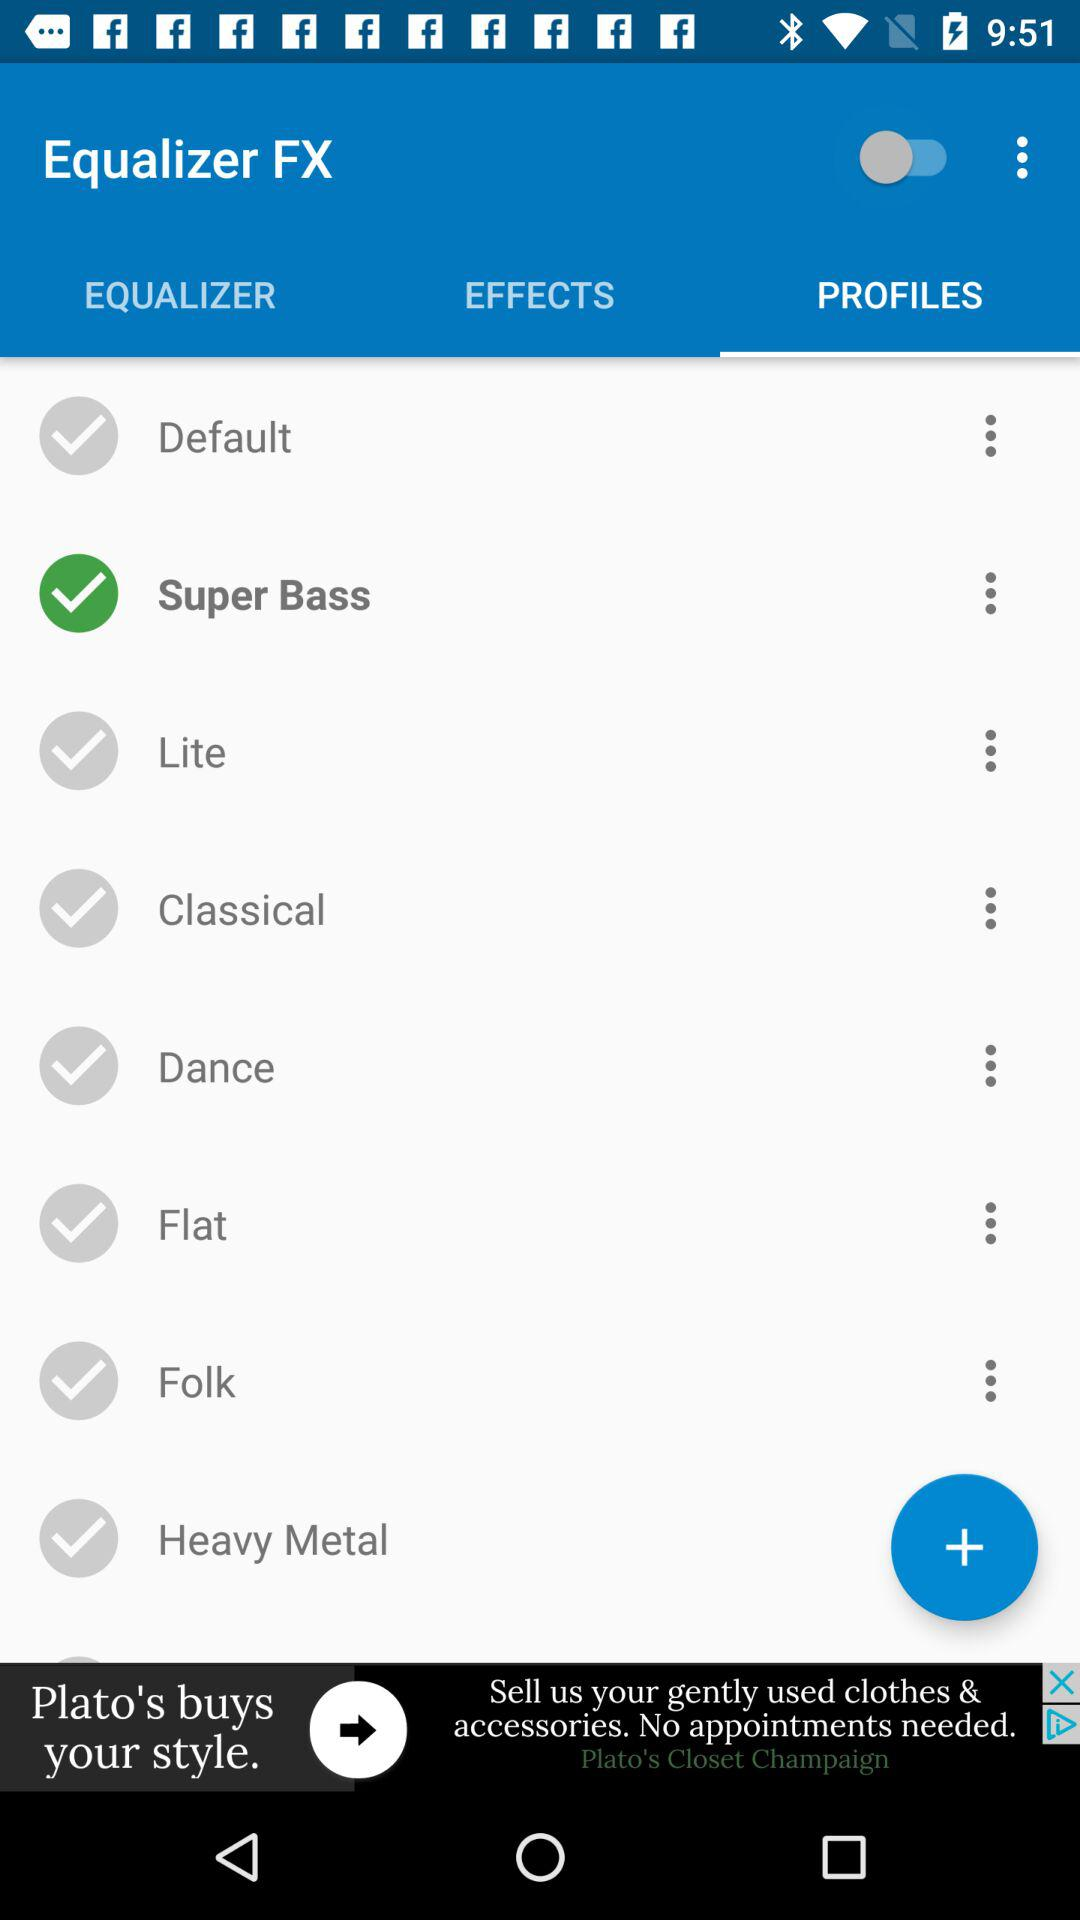Which option is selected in the profiles? The selected option is "Super Bass". 